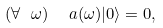<formula> <loc_0><loc_0><loc_500><loc_500>( \forall \ \omega ) \ \ a ( \omega ) | 0 \rangle = 0 ,</formula> 